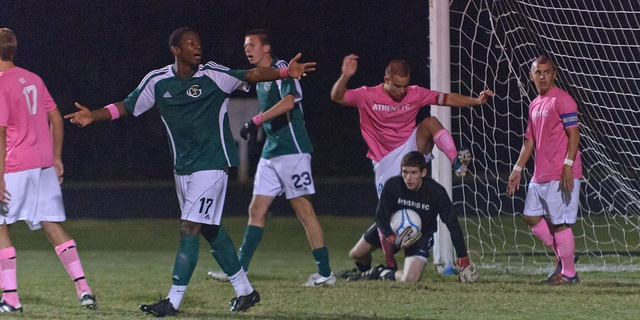Describe the objects in this image and their specific colors. I can see people in black, darkgray, darkblue, and maroon tones, people in black, violet, lavender, and brown tones, people in black, gray, darkgray, and brown tones, people in black, brown, gray, darkgray, and purple tones, and people in black, gray, and darkgray tones in this image. 